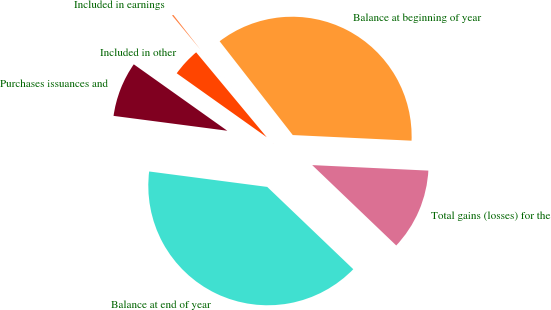Convert chart to OTSL. <chart><loc_0><loc_0><loc_500><loc_500><pie_chart><fcel>Balance at beginning of year<fcel>Included in earnings<fcel>Included in other<fcel>Purchases issuances and<fcel>Balance at end of year<fcel>Total gains (losses) for the<nl><fcel>36.29%<fcel>0.5%<fcel>4.13%<fcel>7.76%<fcel>39.92%<fcel>11.39%<nl></chart> 